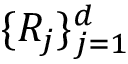Convert formula to latex. <formula><loc_0><loc_0><loc_500><loc_500>\{ R _ { j } \} _ { j = 1 } ^ { d }</formula> 